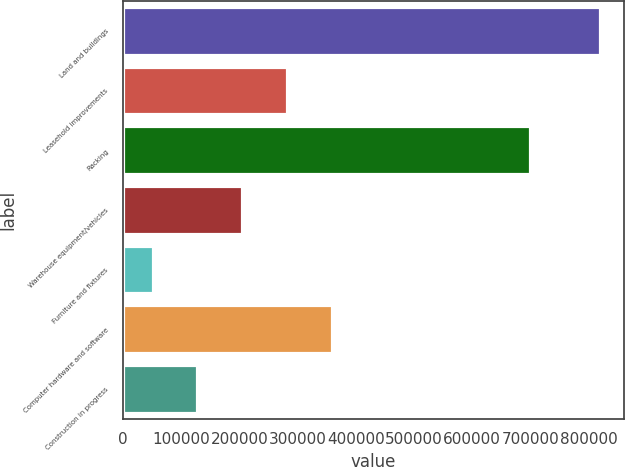Convert chart. <chart><loc_0><loc_0><loc_500><loc_500><bar_chart><fcel>Land and buildings<fcel>Leasehold improvements<fcel>Racking<fcel>Warehouse equipment/vehicles<fcel>Furniture and fixtures<fcel>Computer hardware and software<fcel>Construction in progress<nl><fcel>819221<fcel>281519<fcel>699104<fcel>204704<fcel>51075<fcel>358333<fcel>127890<nl></chart> 